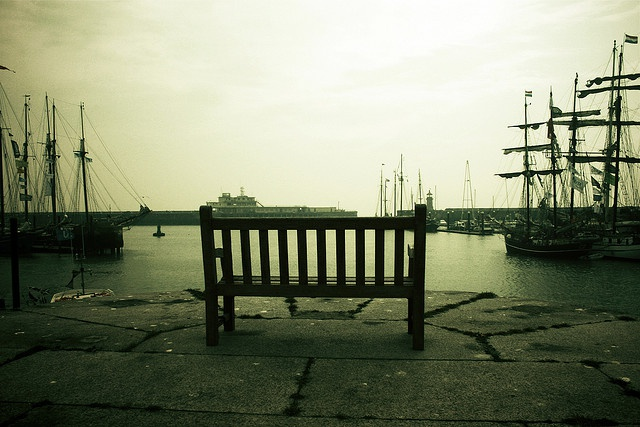Describe the objects in this image and their specific colors. I can see bench in olive, black, tan, khaki, and darkgreen tones, boat in olive, black, tan, and darkgreen tones, boat in olive and darkgreen tones, boat in olive, black, and darkgreen tones, and boat in olive, black, and darkgreen tones in this image. 